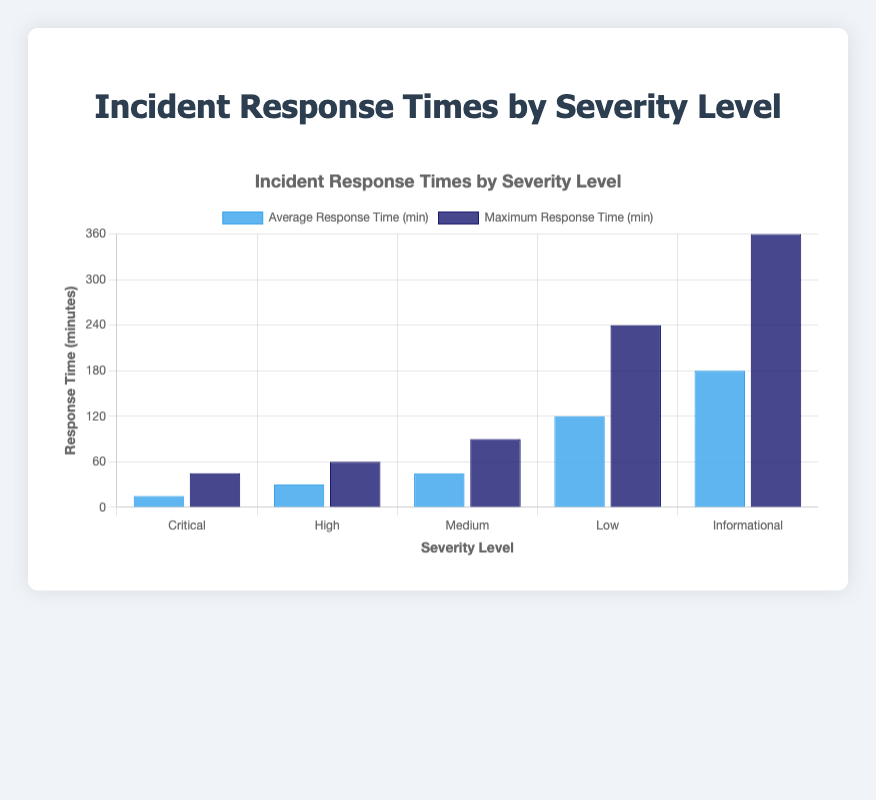Which severity level has the shortest average response time? The "Critical" severity level has the shortest average response time. By examining the heights of the blue bars, the one representing "Critical" is the shortest, at 15 minutes.
Answer: Critical What is the difference in average response time between "High" and "Low" severity levels? The average response time for "High" severity level is 30 minutes, and for "Low" severity level, it is 120 minutes. The difference is calculated as 120 - 30.
Answer: 90 minutes Which personnel has the highest maximum response time, and what is that time? The "Application Support" personnel handling "Informational" severity incidents has the highest maximum response time. By observing the height of the dark blue bars, the one for "Informational" severity is the tallest, at 360 minutes.
Answer: Application Support, 360 minutes How does the maximum response time for "Medium" severity compare to "Critical" severity? The maximum response time for "Medium" severity level is 90 minutes, whereas for "Critical" it is 45 minutes. The former is greater than the latter.
Answer: Medium is greater than Critical Calculate the average of the minimum response times for "High" and "Informational" severity levels. The minimum response time for "High" severity is 20 minutes, and for "Informational" it is 120 minutes. The average is calculated by (20 + 120) / 2.
Answer: 70 minutes What is the median average response time across all severity levels? To find the median, list the average response times in ascending order: 15, 30, 45, 120, 180. The median value is the middle one, which is 45 minutes.
Answer: 45 minutes Which severity level's maximum response time is twice its average response time? For the "Low" severity level, the average response time is 120 minutes and the maximum response time is 240 minutes. 240 is indeed twice 120.
Answer: Low Compare the average response time for "System Administrator" and "Help Desk Technician." Which one is longer and by how much? The average response time for "System Administrator" is 45 minutes, and for "Help Desk Technician" it is 120 minutes. The difference is calculated as 120 - 45.
Answer: Help Desk Technician, 75 minutes What is the total sum of the average response times for all severity levels? Sum up the average response times: 15 (Critical) + 30 (High) + 45 (Medium) + 120 (Low) + 180 (Informational). The total is 390 minutes.
Answer: 390 minutes 